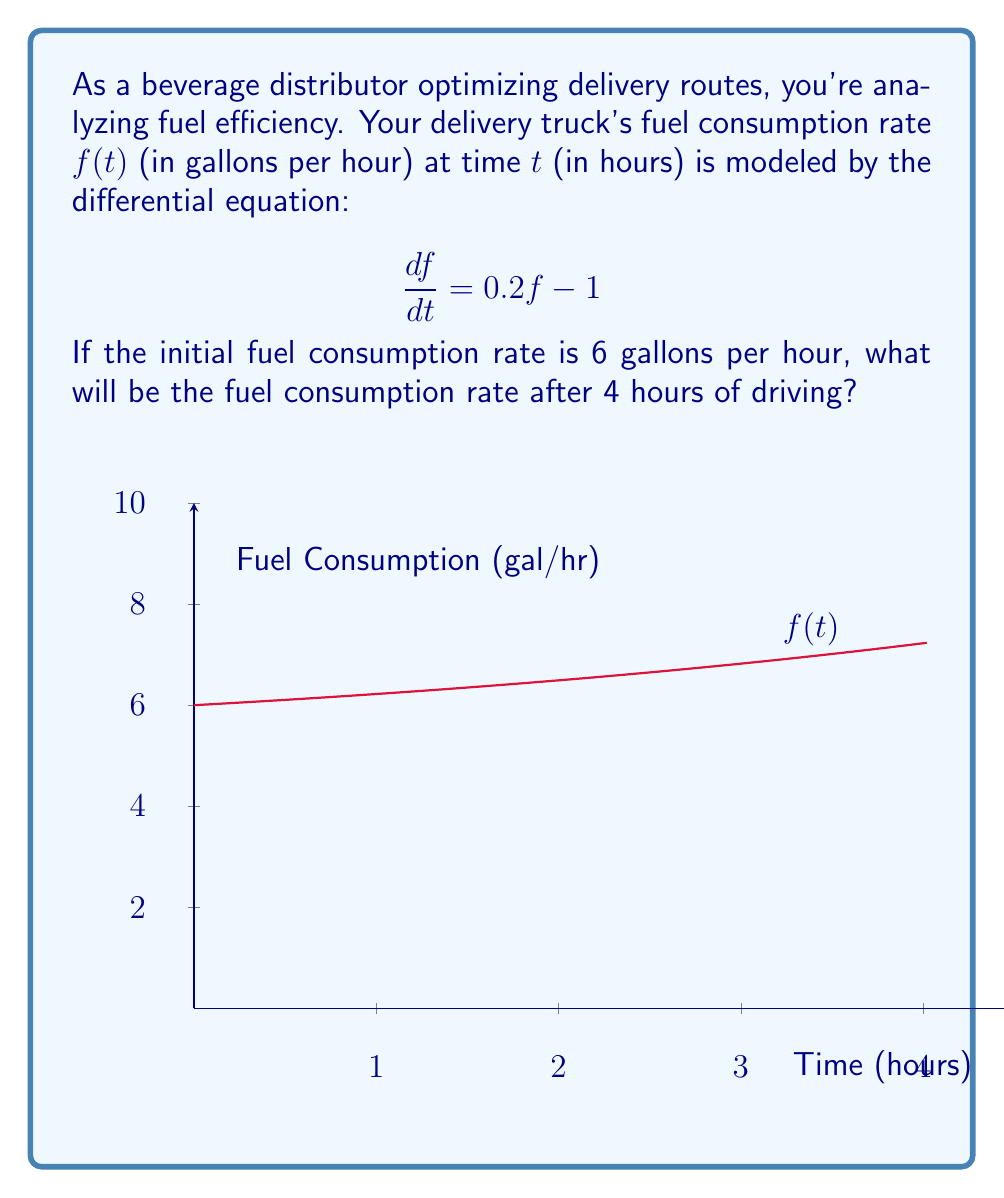Solve this math problem. Let's solve this step-by-step:

1) We have the differential equation $\frac{df}{dt} = 0.2f - 1$ with initial condition $f(0) = 6$.

2) This is a linear first-order differential equation. The general solution is:
   $$f(t) = ce^{0.2t} + 5$$
   where $c$ is a constant we need to determine.

3) Using the initial condition $f(0) = 6$:
   $$6 = ce^{0.2(0)} + 5$$
   $$6 = c + 5$$
   $$c = 1$$

4) Therefore, the particular solution is:
   $$f(t) = e^{0.2t} + 5$$

5) To find the fuel consumption rate after 4 hours, we evaluate $f(4)$:
   $$f(4) = e^{0.2(4)} + 5$$
   $$f(4) = e^{0.8} + 5$$
   $$f(4) \approx 2.2255 + 5 = 7.2255$$

6) Rounding to two decimal places:
   $$f(4) \approx 7.23 \text{ gallons per hour}$$
Answer: 7.23 gallons per hour 